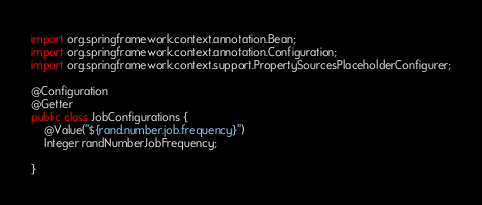<code> <loc_0><loc_0><loc_500><loc_500><_Java_>import org.springframework.context.annotation.Bean;
import org.springframework.context.annotation.Configuration;
import org.springframework.context.support.PropertySourcesPlaceholderConfigurer;

@Configuration
@Getter
public class JobConfigurations {
    @Value("${rand.number.job.frequency}")
    Integer randNumberJobFrequency;

}
</code> 